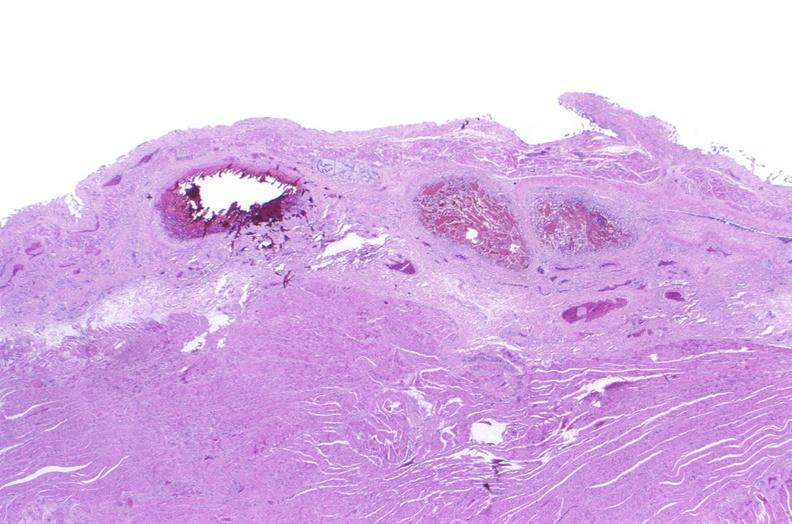where is this from?
Answer the question using a single word or phrase. Gastrointestinal system 